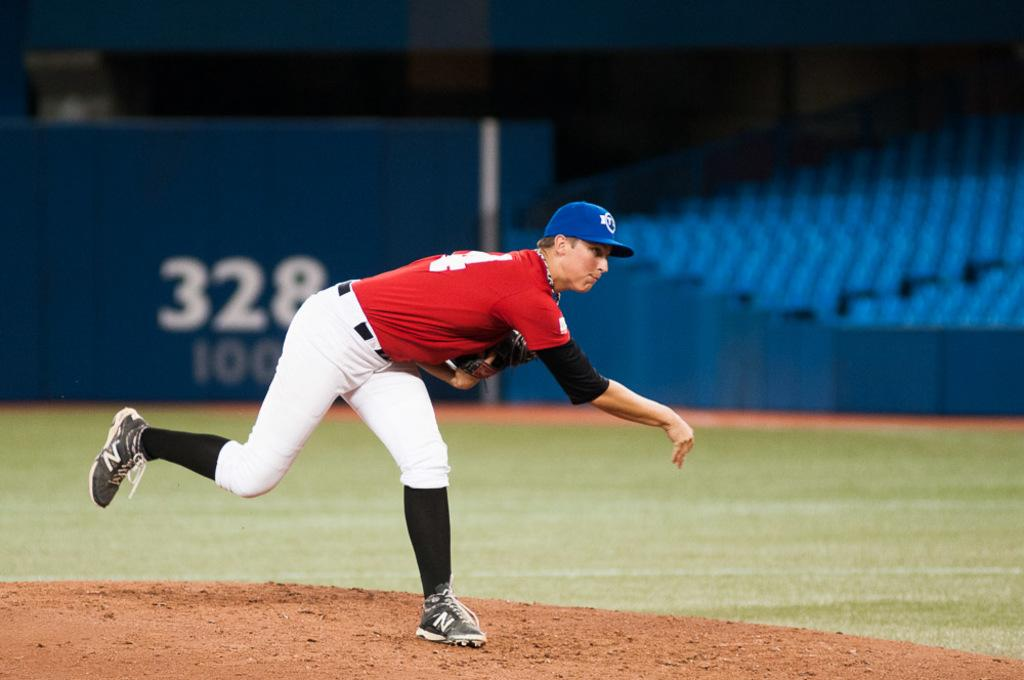<image>
Share a concise interpretation of the image provided. A signboard depicting the number 328 behind a baseball player. 